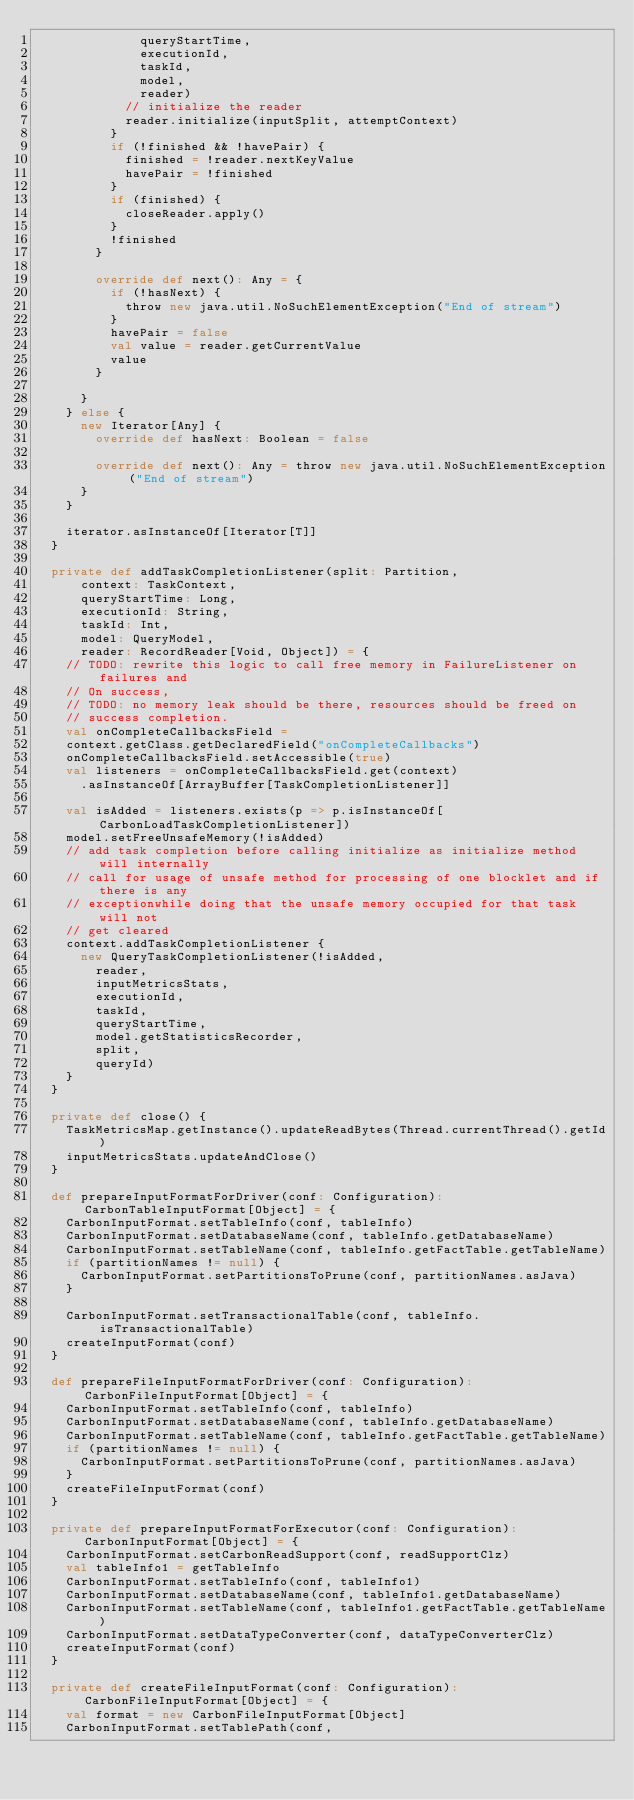Convert code to text. <code><loc_0><loc_0><loc_500><loc_500><_Scala_>              queryStartTime,
              executionId,
              taskId,
              model,
              reader)
            // initialize the reader
            reader.initialize(inputSplit, attemptContext)
          }
          if (!finished && !havePair) {
            finished = !reader.nextKeyValue
            havePair = !finished
          }
          if (finished) {
            closeReader.apply()
          }
          !finished
        }

        override def next(): Any = {
          if (!hasNext) {
            throw new java.util.NoSuchElementException("End of stream")
          }
          havePair = false
          val value = reader.getCurrentValue
          value
        }

      }
    } else {
      new Iterator[Any] {
        override def hasNext: Boolean = false

        override def next(): Any = throw new java.util.NoSuchElementException("End of stream")
      }
    }

    iterator.asInstanceOf[Iterator[T]]
  }

  private def addTaskCompletionListener(split: Partition,
      context: TaskContext,
      queryStartTime: Long,
      executionId: String,
      taskId: Int,
      model: QueryModel,
      reader: RecordReader[Void, Object]) = {
    // TODO: rewrite this logic to call free memory in FailureListener on failures and
    // On success,
    // TODO: no memory leak should be there, resources should be freed on
    // success completion.
    val onCompleteCallbacksField =
    context.getClass.getDeclaredField("onCompleteCallbacks")
    onCompleteCallbacksField.setAccessible(true)
    val listeners = onCompleteCallbacksField.get(context)
      .asInstanceOf[ArrayBuffer[TaskCompletionListener]]

    val isAdded = listeners.exists(p => p.isInstanceOf[CarbonLoadTaskCompletionListener])
    model.setFreeUnsafeMemory(!isAdded)
    // add task completion before calling initialize as initialize method will internally
    // call for usage of unsafe method for processing of one blocklet and if there is any
    // exceptionwhile doing that the unsafe memory occupied for that task will not
    // get cleared
    context.addTaskCompletionListener {
      new QueryTaskCompletionListener(!isAdded,
        reader,
        inputMetricsStats,
        executionId,
        taskId,
        queryStartTime,
        model.getStatisticsRecorder,
        split,
        queryId)
    }
  }

  private def close() {
    TaskMetricsMap.getInstance().updateReadBytes(Thread.currentThread().getId)
    inputMetricsStats.updateAndClose()
  }

  def prepareInputFormatForDriver(conf: Configuration): CarbonTableInputFormat[Object] = {
    CarbonInputFormat.setTableInfo(conf, tableInfo)
    CarbonInputFormat.setDatabaseName(conf, tableInfo.getDatabaseName)
    CarbonInputFormat.setTableName(conf, tableInfo.getFactTable.getTableName)
    if (partitionNames != null) {
      CarbonInputFormat.setPartitionsToPrune(conf, partitionNames.asJava)
    }

    CarbonInputFormat.setTransactionalTable(conf, tableInfo.isTransactionalTable)
    createInputFormat(conf)
  }

  def prepareFileInputFormatForDriver(conf: Configuration): CarbonFileInputFormat[Object] = {
    CarbonInputFormat.setTableInfo(conf, tableInfo)
    CarbonInputFormat.setDatabaseName(conf, tableInfo.getDatabaseName)
    CarbonInputFormat.setTableName(conf, tableInfo.getFactTable.getTableName)
    if (partitionNames != null) {
      CarbonInputFormat.setPartitionsToPrune(conf, partitionNames.asJava)
    }
    createFileInputFormat(conf)
  }

  private def prepareInputFormatForExecutor(conf: Configuration): CarbonInputFormat[Object] = {
    CarbonInputFormat.setCarbonReadSupport(conf, readSupportClz)
    val tableInfo1 = getTableInfo
    CarbonInputFormat.setTableInfo(conf, tableInfo1)
    CarbonInputFormat.setDatabaseName(conf, tableInfo1.getDatabaseName)
    CarbonInputFormat.setTableName(conf, tableInfo1.getFactTable.getTableName)
    CarbonInputFormat.setDataTypeConverter(conf, dataTypeConverterClz)
    createInputFormat(conf)
  }

  private def createFileInputFormat(conf: Configuration): CarbonFileInputFormat[Object] = {
    val format = new CarbonFileInputFormat[Object]
    CarbonInputFormat.setTablePath(conf,</code> 